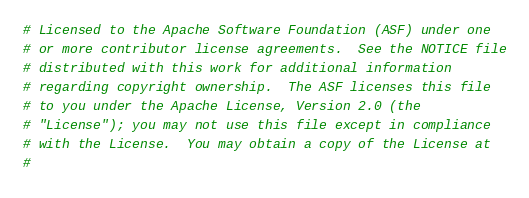Convert code to text. <code><loc_0><loc_0><loc_500><loc_500><_Dockerfile_>
# Licensed to the Apache Software Foundation (ASF) under one
# or more contributor license agreements.  See the NOTICE file
# distributed with this work for additional information
# regarding copyright ownership.  The ASF licenses this file
# to you under the Apache License, Version 2.0 (the
# "License"); you may not use this file except in compliance
# with the License.  You may obtain a copy of the License at
#</code> 